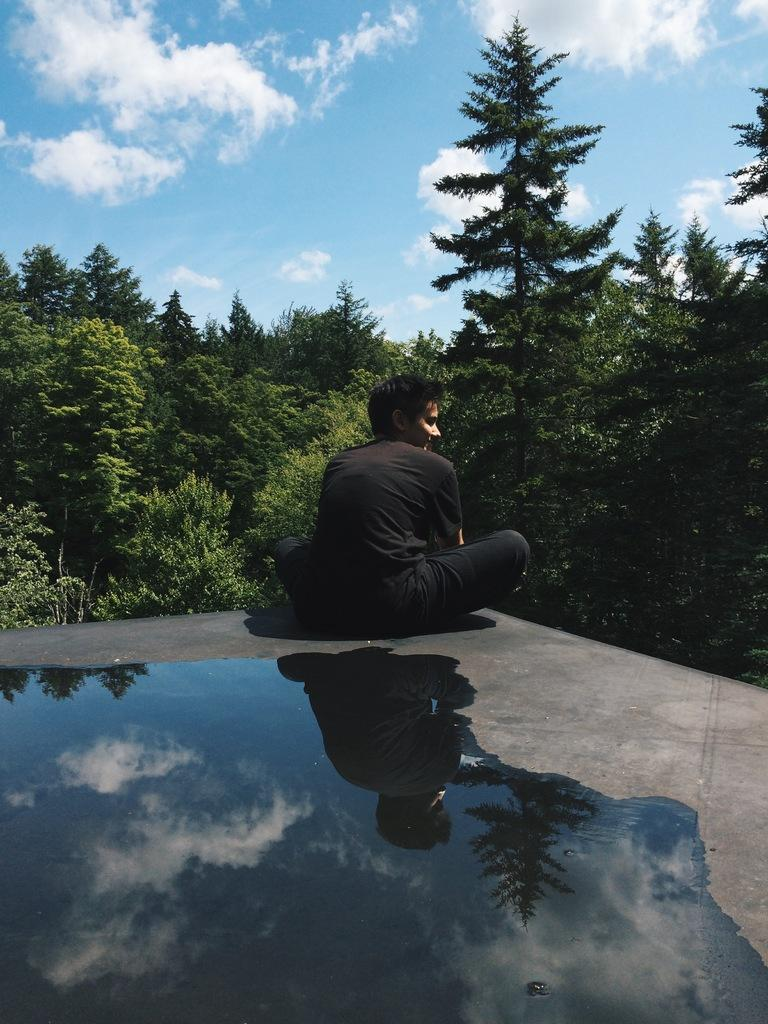What is the primary element in the image? There is water in the image. What is the person in the image doing? The person is sitting in the image. What color is the dress the person is wearing? The person is wearing a black dress. What can be seen in the distance in the image? There are trees visible in the background of the image. What flavor of ice cream does the person in the image prefer? There is no information about the person's ice cream preferences in the image. 